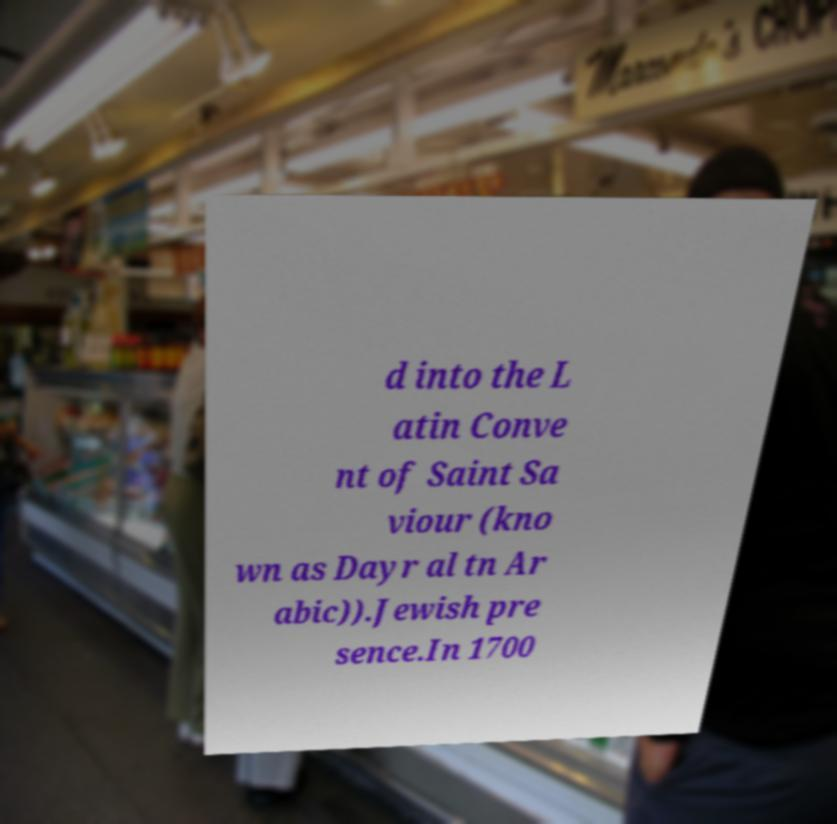Can you accurately transcribe the text from the provided image for me? d into the L atin Conve nt of Saint Sa viour (kno wn as Dayr al tn Ar abic)).Jewish pre sence.In 1700 